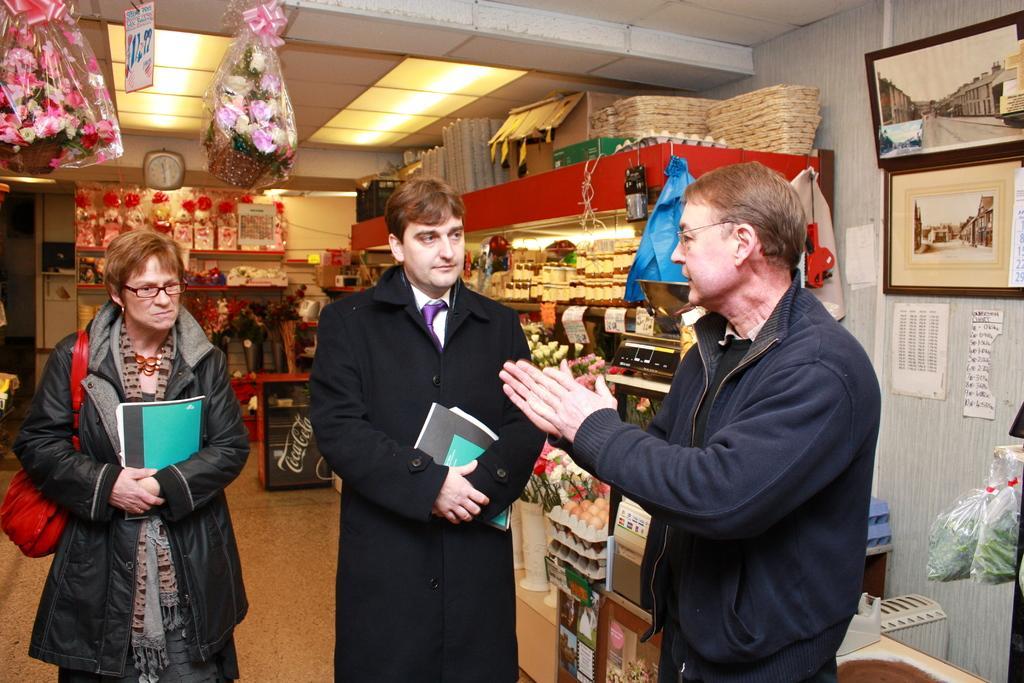Describe this image in one or two sentences. This picture might be taken in store, in this image in the foreground there are three people standing and two of them are holding books. And in the background there are some racks, in the racks there are some cards, flowers, flower pots, packets, egg trays, eggs and some objects. And on the right side of the image there are some photo frames, and posters, plastic covers. And in the covers there is something, and some other objects. And in the background there is clock, and at the top there are flower bouquets and ceiling and some lights. 